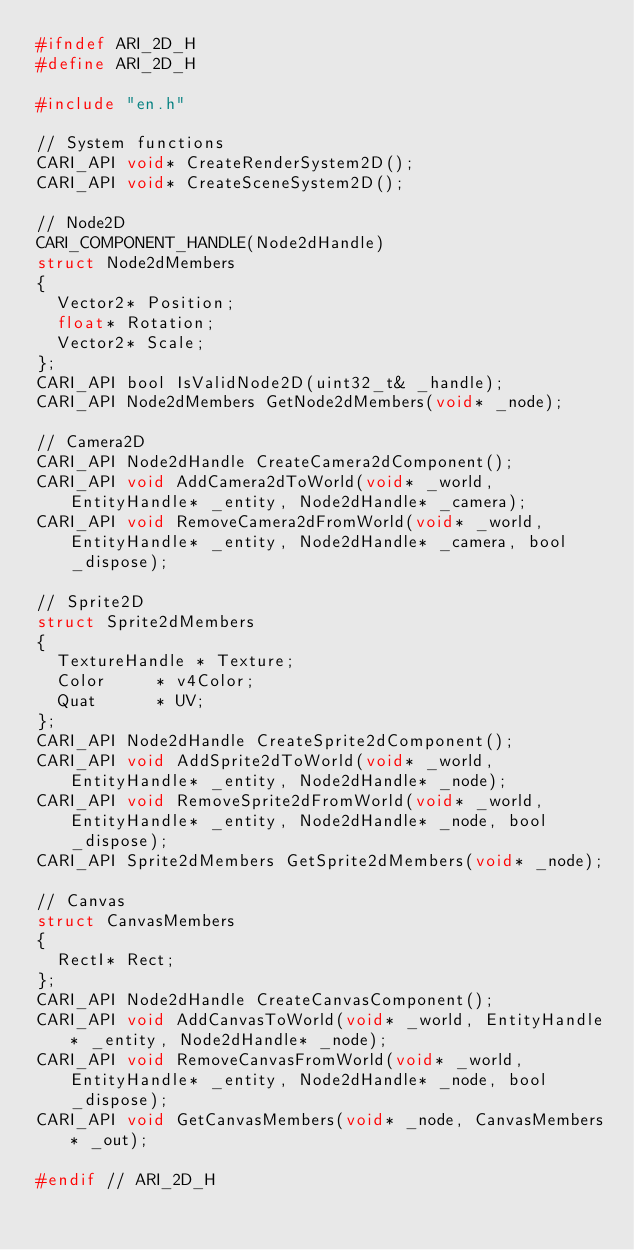<code> <loc_0><loc_0><loc_500><loc_500><_C_>#ifndef ARI_2D_H
#define ARI_2D_H

#include "en.h"

// System functions
CARI_API void* CreateRenderSystem2D();
CARI_API void* CreateSceneSystem2D();

// Node2D
CARI_COMPONENT_HANDLE(Node2dHandle)
struct Node2dMembers
{
	Vector2* Position;
	float* Rotation;
	Vector2* Scale;
};
CARI_API bool IsValidNode2D(uint32_t& _handle);
CARI_API Node2dMembers GetNode2dMembers(void* _node);

// Camera2D
CARI_API Node2dHandle CreateCamera2dComponent();
CARI_API void AddCamera2dToWorld(void* _world, EntityHandle* _entity, Node2dHandle* _camera);
CARI_API void RemoveCamera2dFromWorld(void* _world, EntityHandle* _entity, Node2dHandle* _camera, bool _dispose);

// Sprite2D
struct Sprite2dMembers
{
	TextureHandle	*	Texture;
	Color			*	v4Color;
	Quat			*	UV;
};
CARI_API Node2dHandle CreateSprite2dComponent();
CARI_API void AddSprite2dToWorld(void* _world, EntityHandle* _entity, Node2dHandle* _node);
CARI_API void RemoveSprite2dFromWorld(void* _world, EntityHandle* _entity, Node2dHandle* _node, bool _dispose);
CARI_API Sprite2dMembers GetSprite2dMembers(void* _node);

// Canvas
struct CanvasMembers
{
	RectI* Rect;
};
CARI_API Node2dHandle CreateCanvasComponent();
CARI_API void AddCanvasToWorld(void* _world, EntityHandle* _entity, Node2dHandle* _node);
CARI_API void RemoveCanvasFromWorld(void* _world, EntityHandle* _entity, Node2dHandle* _node, bool _dispose);
CARI_API void GetCanvasMembers(void* _node, CanvasMembers* _out);

#endif // ARI_2D_H</code> 